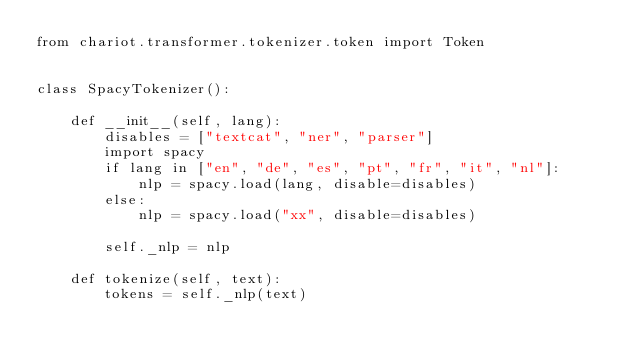<code> <loc_0><loc_0><loc_500><loc_500><_Python_>from chariot.transformer.tokenizer.token import Token


class SpacyTokenizer():

    def __init__(self, lang):
        disables = ["textcat", "ner", "parser"]
        import spacy
        if lang in ["en", "de", "es", "pt", "fr", "it", "nl"]:
            nlp = spacy.load(lang, disable=disables)
        else:
            nlp = spacy.load("xx", disable=disables)

        self._nlp = nlp

    def tokenize(self, text):
        tokens = self._nlp(text)</code> 